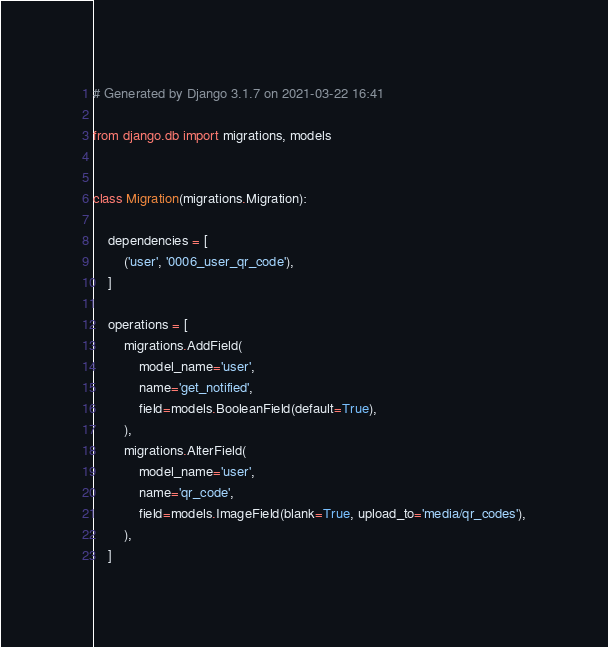Convert code to text. <code><loc_0><loc_0><loc_500><loc_500><_Python_># Generated by Django 3.1.7 on 2021-03-22 16:41

from django.db import migrations, models


class Migration(migrations.Migration):

    dependencies = [
        ('user', '0006_user_qr_code'),
    ]

    operations = [
        migrations.AddField(
            model_name='user',
            name='get_notified',
            field=models.BooleanField(default=True),
        ),
        migrations.AlterField(
            model_name='user',
            name='qr_code',
            field=models.ImageField(blank=True, upload_to='media/qr_codes'),
        ),
    ]
</code> 